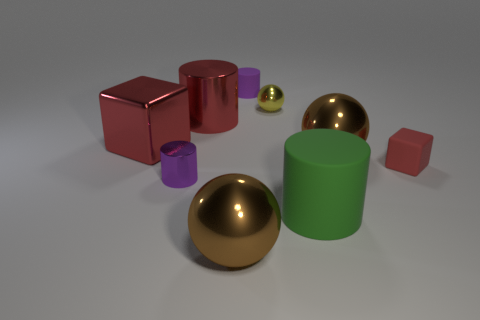Is the color of the object to the left of the small purple metallic object the same as the big shiny cylinder?
Your answer should be very brief. Yes. There is a big red thing that is in front of the metallic cylinder that is on the right side of the purple object in front of the purple matte object; what shape is it?
Provide a succinct answer. Cube. What number of purple metallic cylinders are behind the tiny purple object that is behind the small yellow object?
Offer a terse response. 0. Is the tiny red block made of the same material as the tiny ball?
Provide a succinct answer. No. What number of small purple things are on the left side of the brown metallic ball that is in front of the large ball to the right of the large rubber cylinder?
Give a very brief answer. 1. There is a big sphere to the left of the tiny yellow metal thing; what is its color?
Your answer should be very brief. Brown. What shape is the big brown object that is right of the ball in front of the red rubber object?
Provide a succinct answer. Sphere. Is the large metal cylinder the same color as the small matte block?
Provide a succinct answer. Yes. What number of spheres are big matte objects or tiny yellow objects?
Make the answer very short. 1. The thing that is both in front of the tiny red object and left of the large red metal cylinder is made of what material?
Keep it short and to the point. Metal. 